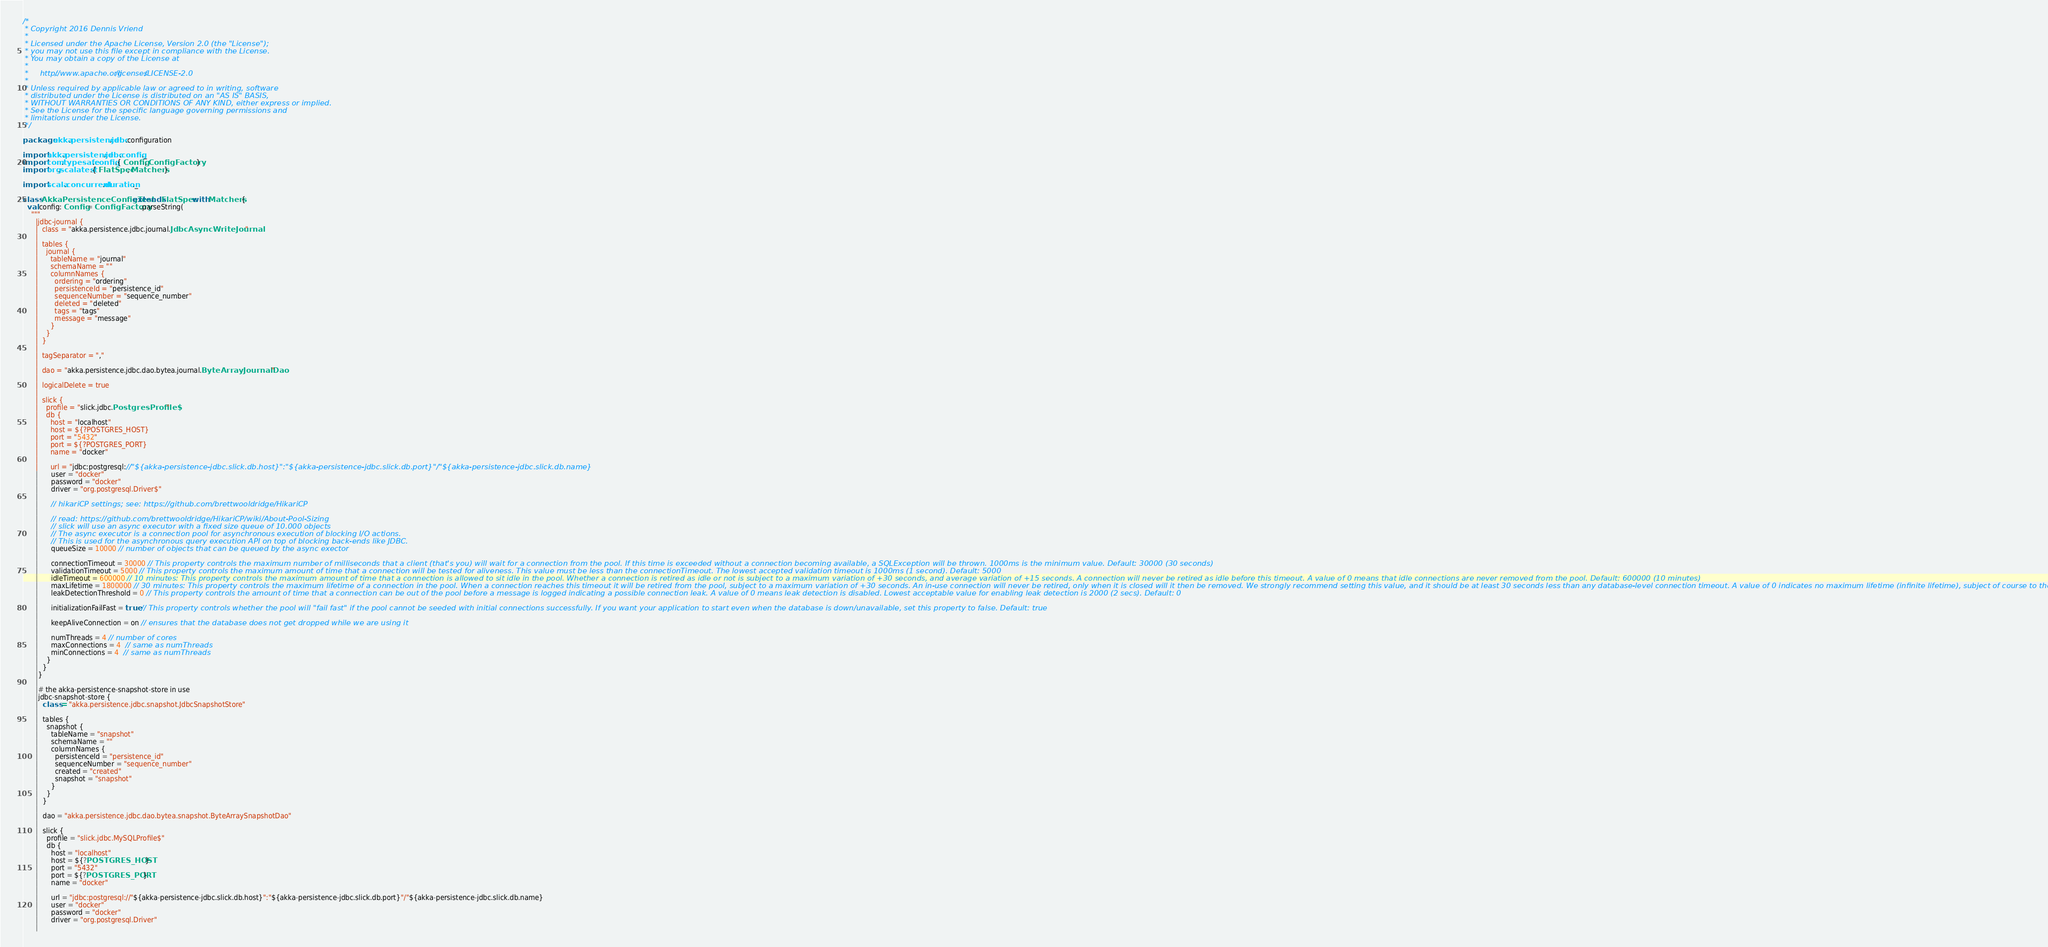<code> <loc_0><loc_0><loc_500><loc_500><_Scala_>/*
 * Copyright 2016 Dennis Vriend
 *
 * Licensed under the Apache License, Version 2.0 (the "License");
 * you may not use this file except in compliance with the License.
 * You may obtain a copy of the License at
 *
 *     http://www.apache.org/licenses/LICENSE-2.0
 *
 * Unless required by applicable law or agreed to in writing, software
 * distributed under the License is distributed on an "AS IS" BASIS,
 * WITHOUT WARRANTIES OR CONDITIONS OF ANY KIND, either express or implied.
 * See the License for the specific language governing permissions and
 * limitations under the License.
 */

package akka.persistence.jdbc.configuration

import akka.persistence.jdbc.config._
import com.typesafe.config.{ Config, ConfigFactory }
import org.scalatest.{ FlatSpec, Matchers }

import scala.concurrent.duration._

class AkkaPersistenceConfigTest extends FlatSpec with Matchers {
  val config: Config = ConfigFactory.parseString(
    """
      |jdbc-journal {
      |  class = "akka.persistence.jdbc.journal.JdbcAsyncWriteJournal"
      |
      |  tables {
      |    journal {
      |      tableName = "journal"
      |      schemaName = ""
      |      columnNames {
      |        ordering = "ordering"
      |        persistenceId = "persistence_id"
      |        sequenceNumber = "sequence_number"
      |        deleted = "deleted"
      |        tags = "tags"
      |        message = "message"
      |      }
      |    }
      |  }
      |
      |  tagSeparator = ","
      |
      |  dao = "akka.persistence.jdbc.dao.bytea.journal.ByteArrayJournalDao"
      |
      |  logicalDelete = true
      |
      |  slick {
      |    profile = "slick.jdbc.PostgresProfile$"
      |    db {
      |      host = "localhost"
      |      host = ${?POSTGRES_HOST}
      |      port = "5432"
      |      port = ${?POSTGRES_PORT}
      |      name = "docker"
      |
      |      url = "jdbc:postgresql://"${akka-persistence-jdbc.slick.db.host}":"${akka-persistence-jdbc.slick.db.port}"/"${akka-persistence-jdbc.slick.db.name}
      |      user = "docker"
      |      password = "docker"
      |      driver = "org.postgresql.Driver$"
      |
      |      // hikariCP settings; see: https://github.com/brettwooldridge/HikariCP
      |
      |      // read: https://github.com/brettwooldridge/HikariCP/wiki/About-Pool-Sizing
      |      // slick will use an async executor with a fixed size queue of 10.000 objects
      |      // The async executor is a connection pool for asynchronous execution of blocking I/O actions.
      |      // This is used for the asynchronous query execution API on top of blocking back-ends like JDBC.
      |      queueSize = 10000 // number of objects that can be queued by the async exector
      |
      |      connectionTimeout = 30000 // This property controls the maximum number of milliseconds that a client (that's you) will wait for a connection from the pool. If this time is exceeded without a connection becoming available, a SQLException will be thrown. 1000ms is the minimum value. Default: 30000 (30 seconds)
      |      validationTimeout = 5000 // This property controls the maximum amount of time that a connection will be tested for aliveness. This value must be less than the connectionTimeout. The lowest accepted validation timeout is 1000ms (1 second). Default: 5000
      |      idleTimeout = 600000 // 10 minutes: This property controls the maximum amount of time that a connection is allowed to sit idle in the pool. Whether a connection is retired as idle or not is subject to a maximum variation of +30 seconds, and average variation of +15 seconds. A connection will never be retired as idle before this timeout. A value of 0 means that idle connections are never removed from the pool. Default: 600000 (10 minutes)
      |      maxLifetime = 1800000 // 30 minutes: This property controls the maximum lifetime of a connection in the pool. When a connection reaches this timeout it will be retired from the pool, subject to a maximum variation of +30 seconds. An in-use connection will never be retired, only when it is closed will it then be removed. We strongly recommend setting this value, and it should be at least 30 seconds less than any database-level connection timeout. A value of 0 indicates no maximum lifetime (infinite lifetime), subject of course to the idleTimeout setting. Default: 1800000 (30 minutes)
      |      leakDetectionThreshold = 0 // This property controls the amount of time that a connection can be out of the pool before a message is logged indicating a possible connection leak. A value of 0 means leak detection is disabled. Lowest acceptable value for enabling leak detection is 2000 (2 secs). Default: 0
      |
      |      initializationFailFast = true // This property controls whether the pool will "fail fast" if the pool cannot be seeded with initial connections successfully. If you want your application to start even when the database is down/unavailable, set this property to false. Default: true
      |
      |      keepAliveConnection = on // ensures that the database does not get dropped while we are using it
      |
      |      numThreads = 4 // number of cores
      |      maxConnections = 4  // same as numThreads
      |      minConnections = 4  // same as numThreads
      |    }
      |  }
      |}
      |
      |# the akka-persistence-snapshot-store in use
      |jdbc-snapshot-store {
      |  class = "akka.persistence.jdbc.snapshot.JdbcSnapshotStore"
      |
      |  tables {
      |    snapshot {
      |      tableName = "snapshot"
      |      schemaName = ""
      |      columnNames {
      |        persistenceId = "persistence_id"
      |        sequenceNumber = "sequence_number"
      |        created = "created"
      |        snapshot = "snapshot"
      |      }
      |    }
      |  }
      |
      |  dao = "akka.persistence.jdbc.dao.bytea.snapshot.ByteArraySnapshotDao"
      |
      |  slick {
      |    profile = "slick.jdbc.MySQLProfile$"
      |    db {
      |      host = "localhost"
      |      host = ${?POSTGRES_HOST}
      |      port = "5432"
      |      port = ${?POSTGRES_PORT}
      |      name = "docker"
      |
      |      url = "jdbc:postgresql://"${akka-persistence-jdbc.slick.db.host}":"${akka-persistence-jdbc.slick.db.port}"/"${akka-persistence-jdbc.slick.db.name}
      |      user = "docker"
      |      password = "docker"
      |      driver = "org.postgresql.Driver"
      |</code> 